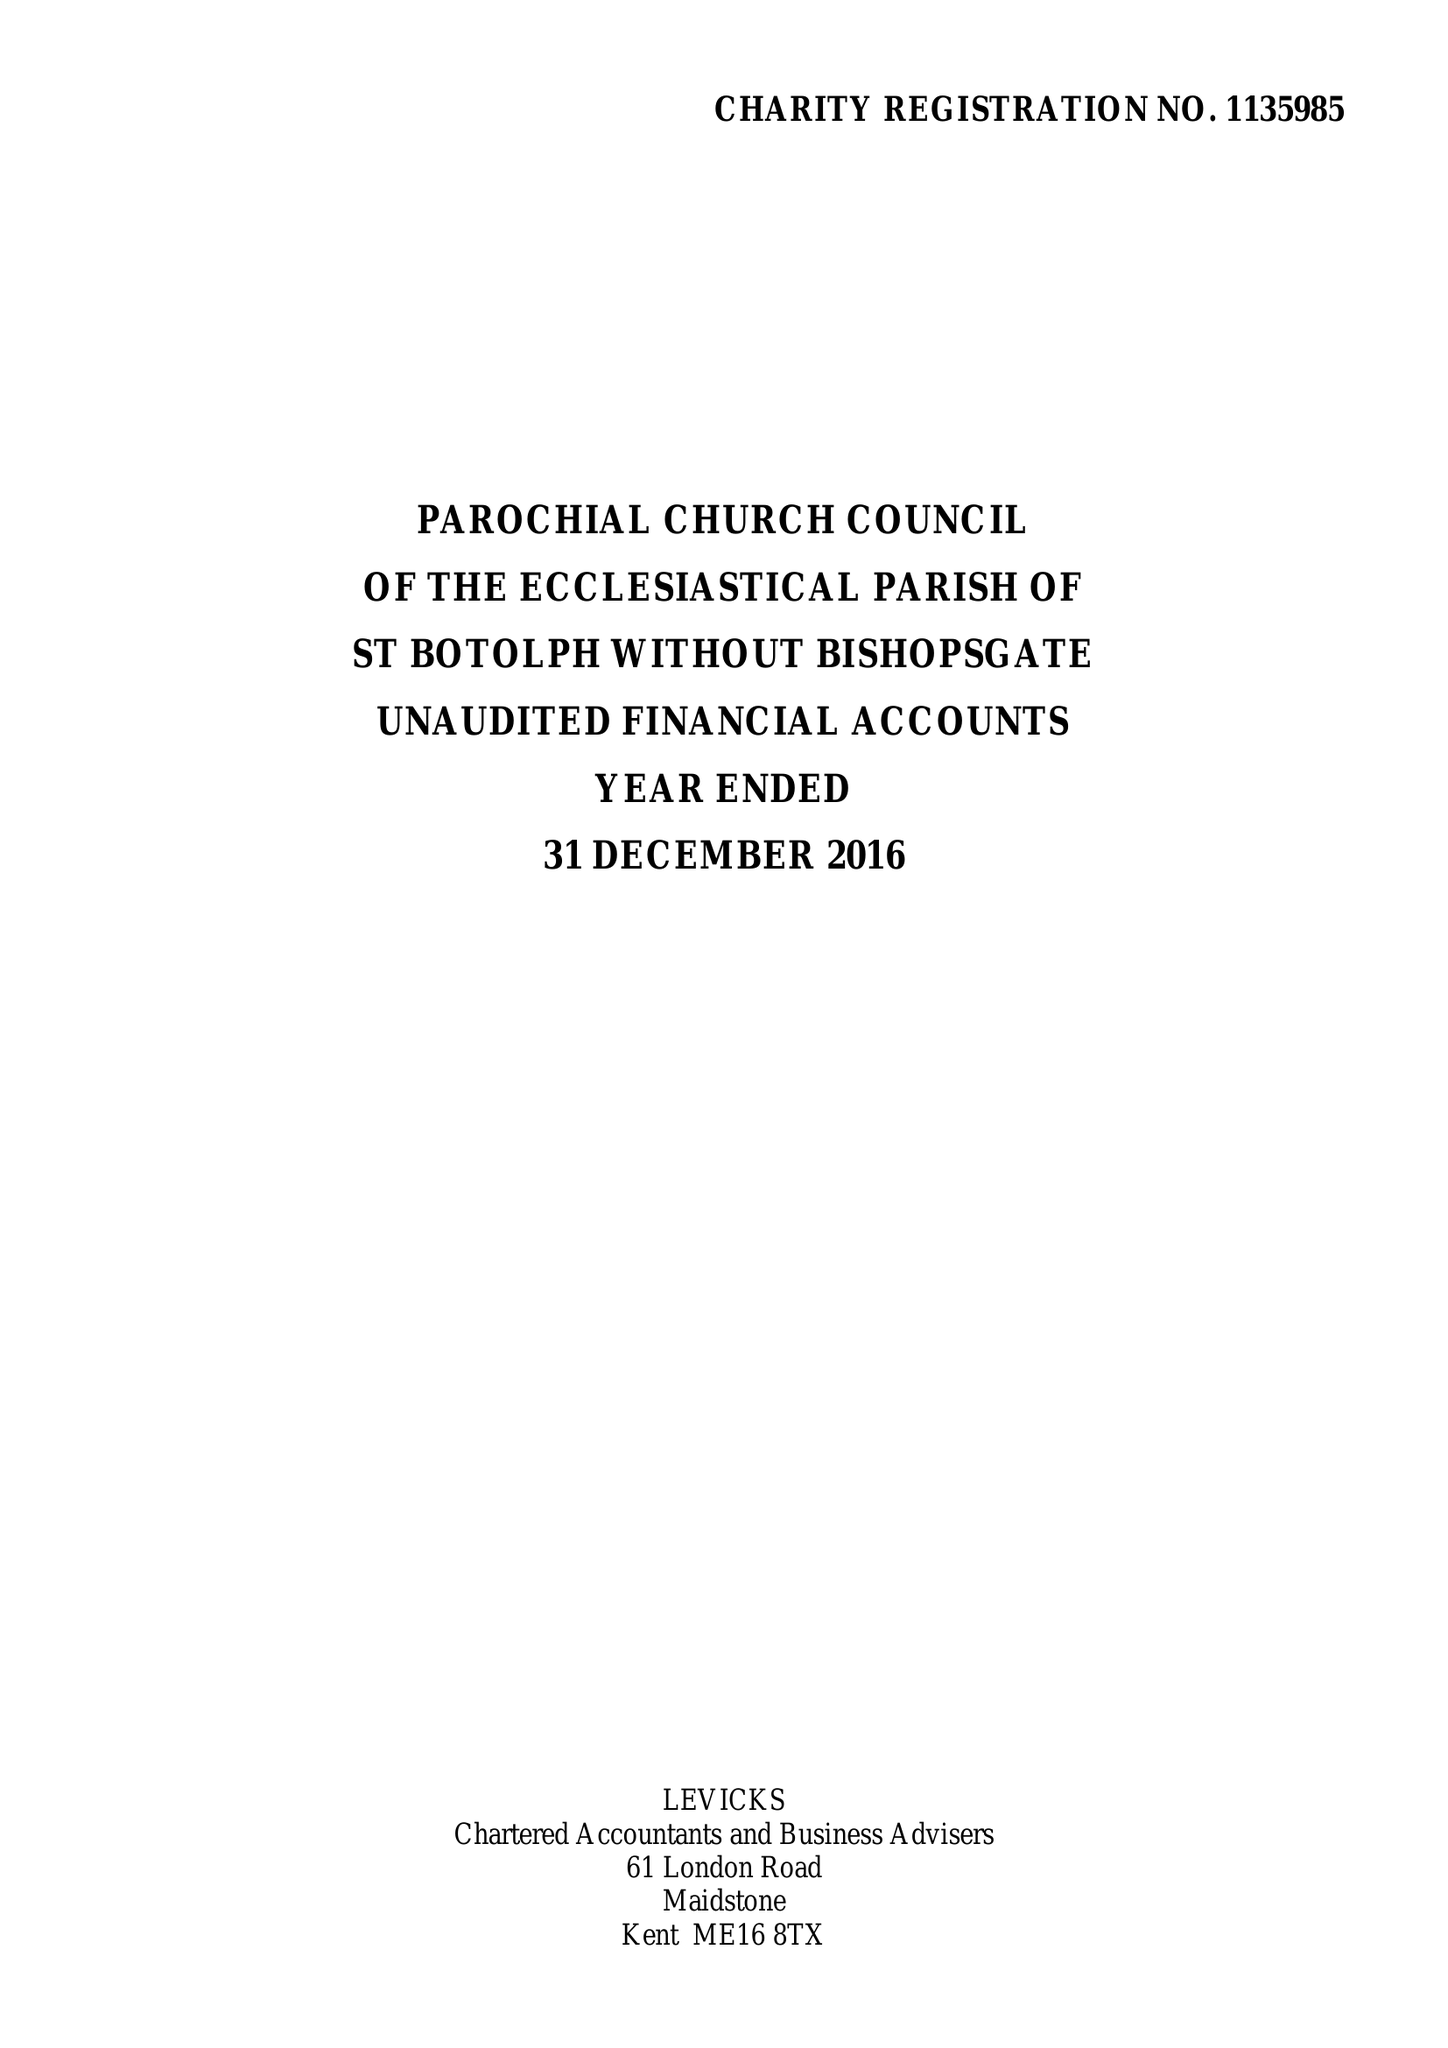What is the value for the income_annually_in_british_pounds?
Answer the question using a single word or phrase. 376379.00 